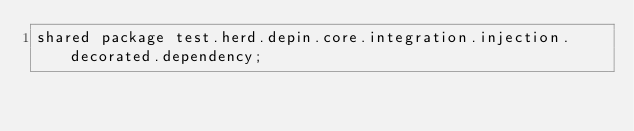<code> <loc_0><loc_0><loc_500><loc_500><_Ceylon_>shared package test.herd.depin.core.integration.injection.decorated.dependency;
</code> 